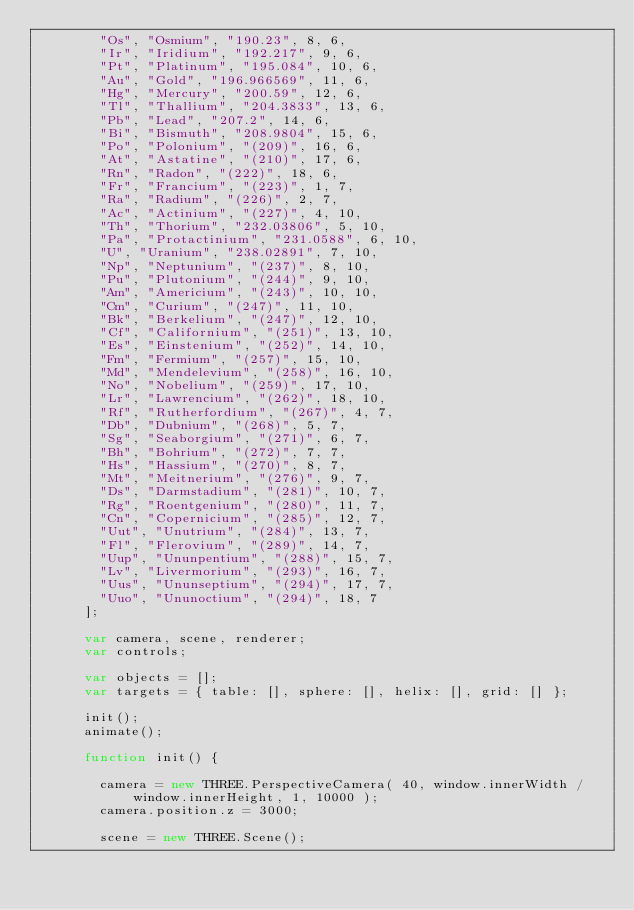<code> <loc_0><loc_0><loc_500><loc_500><_JavaScript_>				"Os", "Osmium", "190.23", 8, 6,
				"Ir", "Iridium", "192.217", 9, 6,
				"Pt", "Platinum", "195.084", 10, 6,
				"Au", "Gold", "196.966569", 11, 6,
				"Hg", "Mercury", "200.59", 12, 6,
				"Tl", "Thallium", "204.3833", 13, 6,
				"Pb", "Lead", "207.2", 14, 6,
				"Bi", "Bismuth", "208.9804", 15, 6,
				"Po", "Polonium", "(209)", 16, 6,
				"At", "Astatine", "(210)", 17, 6,
				"Rn", "Radon", "(222)", 18, 6,
				"Fr", "Francium", "(223)", 1, 7,
				"Ra", "Radium", "(226)", 2, 7,
				"Ac", "Actinium", "(227)", 4, 10,
				"Th", "Thorium", "232.03806", 5, 10,
				"Pa", "Protactinium", "231.0588", 6, 10,
				"U", "Uranium", "238.02891", 7, 10,
				"Np", "Neptunium", "(237)", 8, 10,
				"Pu", "Plutonium", "(244)", 9, 10,
				"Am", "Americium", "(243)", 10, 10,
				"Cm", "Curium", "(247)", 11, 10,
				"Bk", "Berkelium", "(247)", 12, 10,
				"Cf", "Californium", "(251)", 13, 10,
				"Es", "Einstenium", "(252)", 14, 10,
				"Fm", "Fermium", "(257)", 15, 10,
				"Md", "Mendelevium", "(258)", 16, 10,
				"No", "Nobelium", "(259)", 17, 10,
				"Lr", "Lawrencium", "(262)", 18, 10,
				"Rf", "Rutherfordium", "(267)", 4, 7,
				"Db", "Dubnium", "(268)", 5, 7,
				"Sg", "Seaborgium", "(271)", 6, 7,
				"Bh", "Bohrium", "(272)", 7, 7,
				"Hs", "Hassium", "(270)", 8, 7,
				"Mt", "Meitnerium", "(276)", 9, 7,
				"Ds", "Darmstadium", "(281)", 10, 7,
				"Rg", "Roentgenium", "(280)", 11, 7,
				"Cn", "Copernicium", "(285)", 12, 7,
				"Uut", "Unutrium", "(284)", 13, 7,
				"Fl", "Flerovium", "(289)", 14, 7,
				"Uup", "Ununpentium", "(288)", 15, 7,
				"Lv", "Livermorium", "(293)", 16, 7,
				"Uus", "Ununseptium", "(294)", 17, 7,
				"Uuo", "Ununoctium", "(294)", 18, 7
			];

			var camera, scene, renderer;
			var controls;

			var objects = [];
			var targets = { table: [], sphere: [], helix: [], grid: [] };

			init();
			animate();

			function init() {

				camera = new THREE.PerspectiveCamera( 40, window.innerWidth / window.innerHeight, 1, 10000 );
				camera.position.z = 3000;

				scene = new THREE.Scene();
</code> 